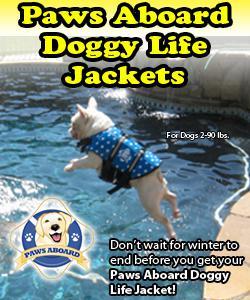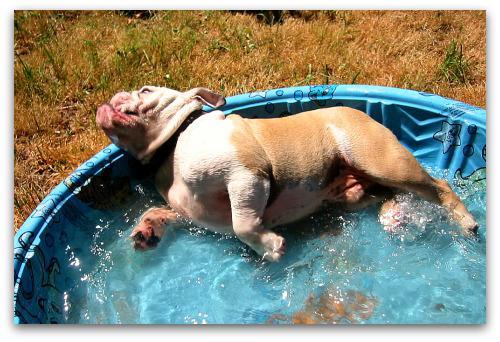The first image is the image on the left, the second image is the image on the right. Examine the images to the left and right. Is the description "A stout brown-and-white bulldog is by himself in a blue kiddie pool in one image, and the other image shows a dog that is above the water of a larger swimming pool." accurate? Answer yes or no. Yes. The first image is the image on the left, the second image is the image on the right. Examine the images to the left and right. Is the description "The left image contains at least two dogs." accurate? Answer yes or no. No. 